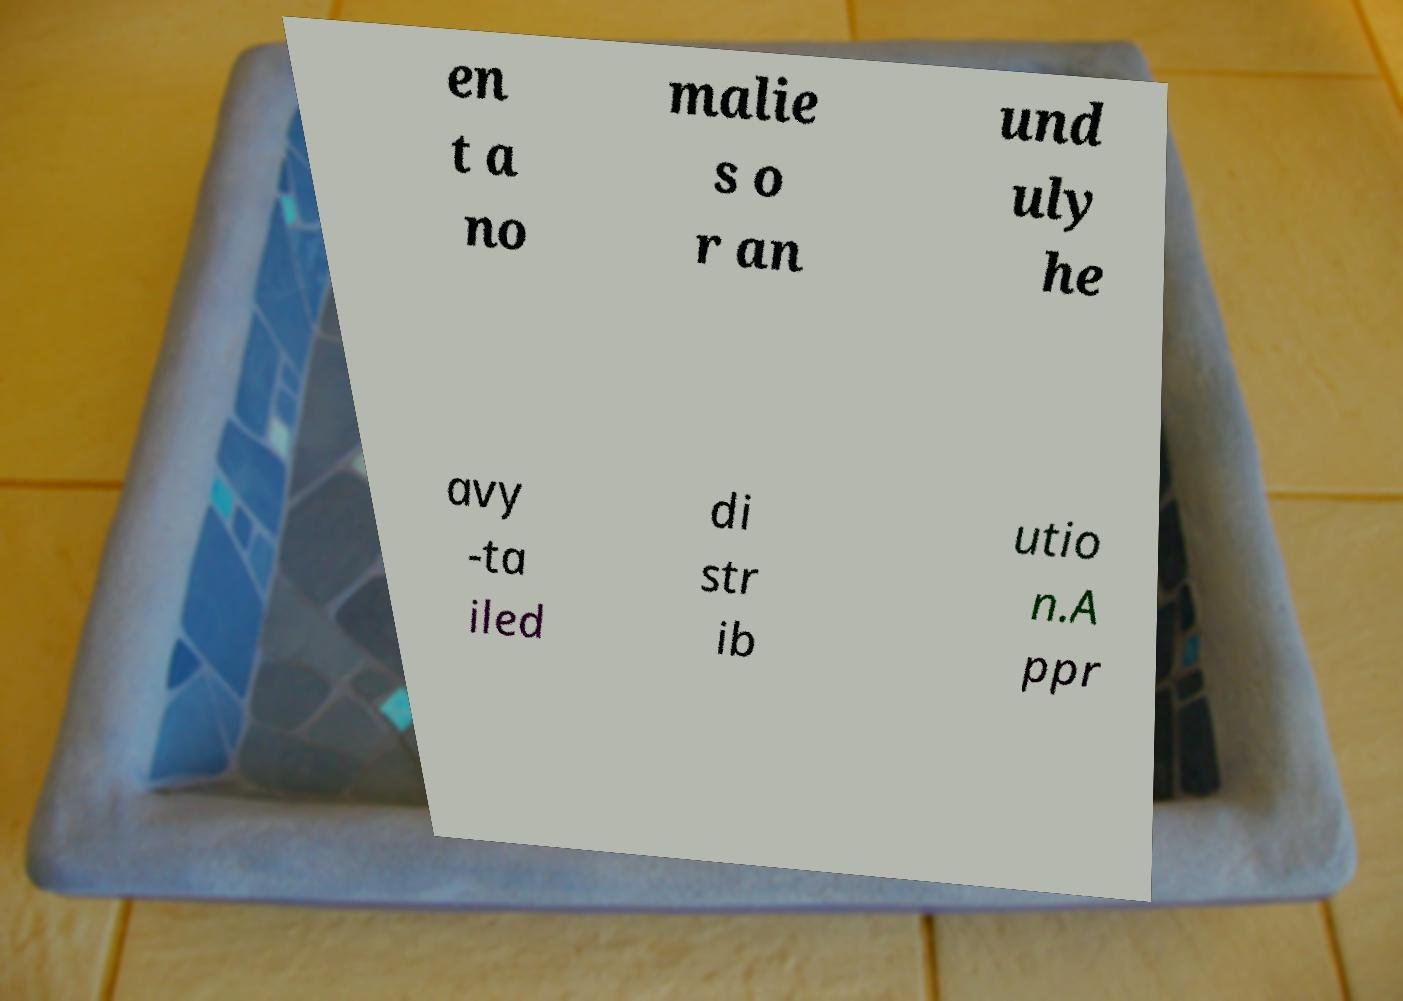Please read and relay the text visible in this image. What does it say? en t a no malie s o r an und uly he avy -ta iled di str ib utio n.A ppr 